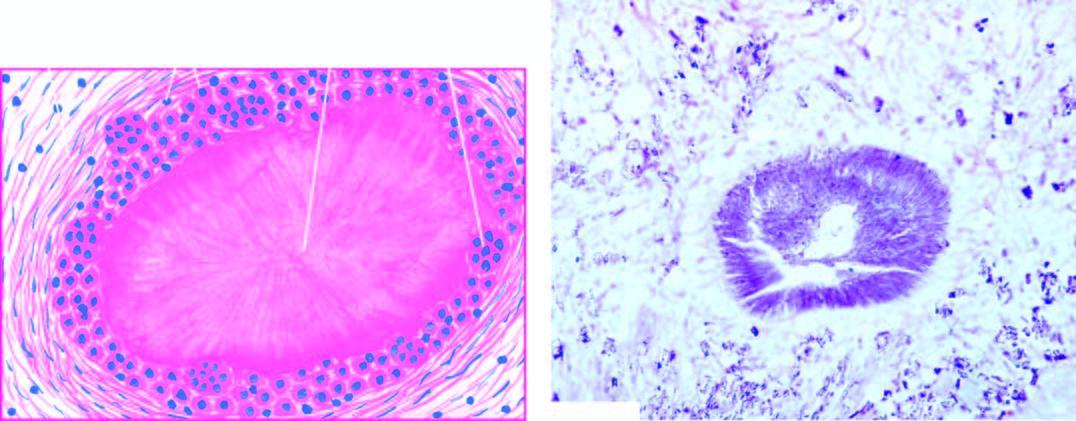what is surrounded by inflammatory cells, fibroblasts and occasional giant cells?
Answer the question using a single word or phrase. Gouty tophus 